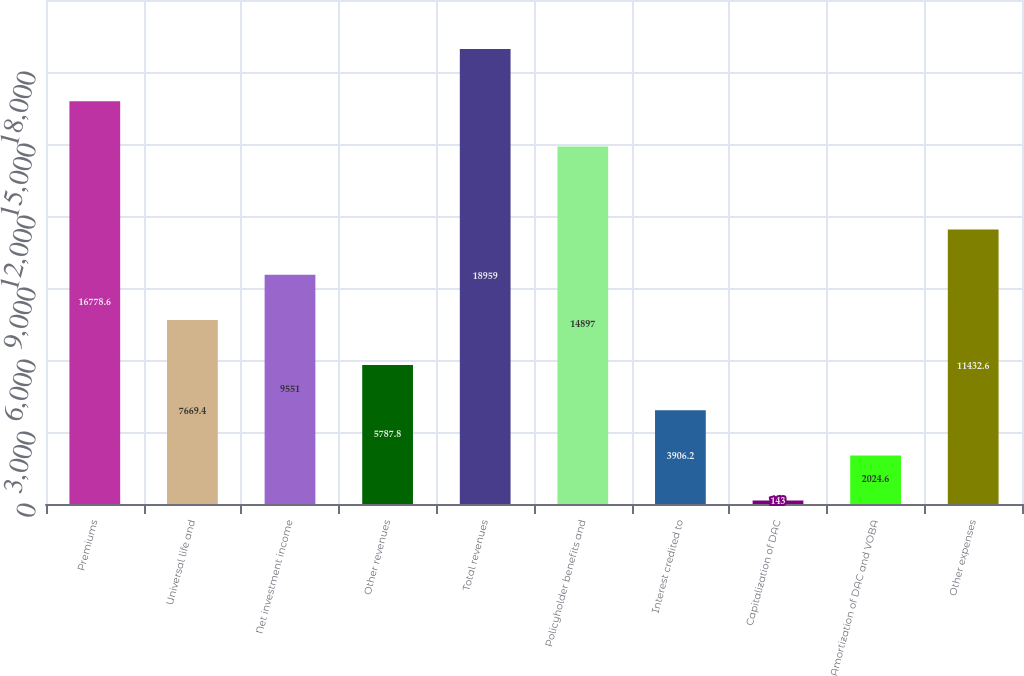Convert chart. <chart><loc_0><loc_0><loc_500><loc_500><bar_chart><fcel>Premiums<fcel>Universal life and<fcel>Net investment income<fcel>Other revenues<fcel>Total revenues<fcel>Policyholder benefits and<fcel>Interest credited to<fcel>Capitalization of DAC<fcel>Amortization of DAC and VOBA<fcel>Other expenses<nl><fcel>16778.6<fcel>7669.4<fcel>9551<fcel>5787.8<fcel>18959<fcel>14897<fcel>3906.2<fcel>143<fcel>2024.6<fcel>11432.6<nl></chart> 